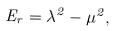<formula> <loc_0><loc_0><loc_500><loc_500>E _ { r } = \lambda ^ { 2 } - \mu ^ { 2 } ,</formula> 